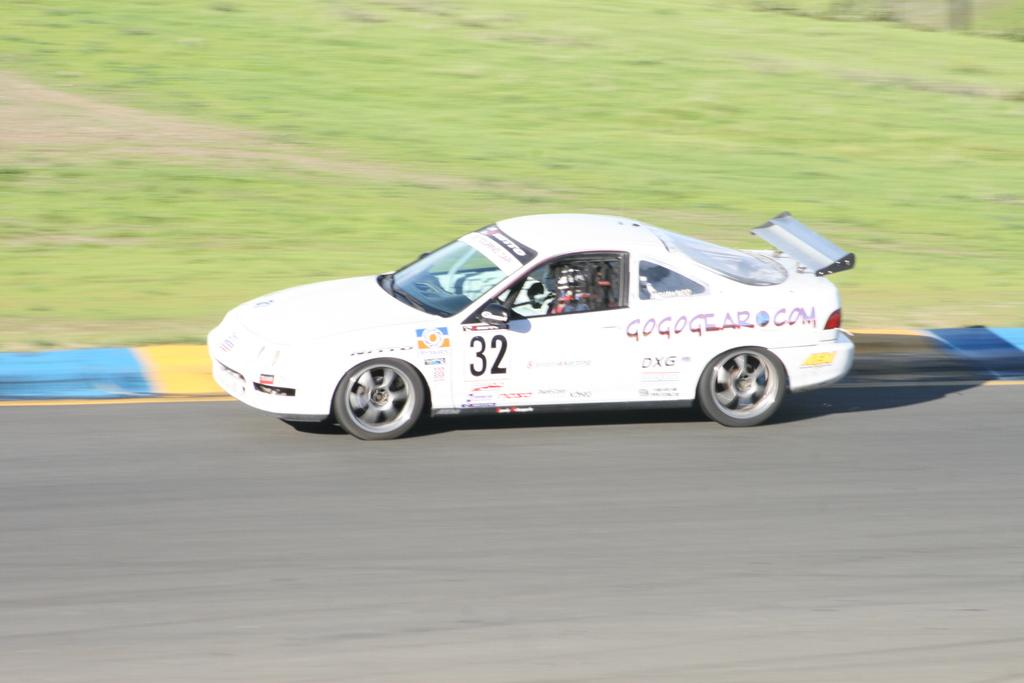Who is present in the image? There is a person in the image. What is the person doing in the image? The person is riding a white car. Where is the car located in the image? The car is on the road. What can be seen in the background of the image? There is grass visible in the background of the image. What type of stove is being used by the person in the image? There is no stove present in the image; the person is riding a white car on the road. 